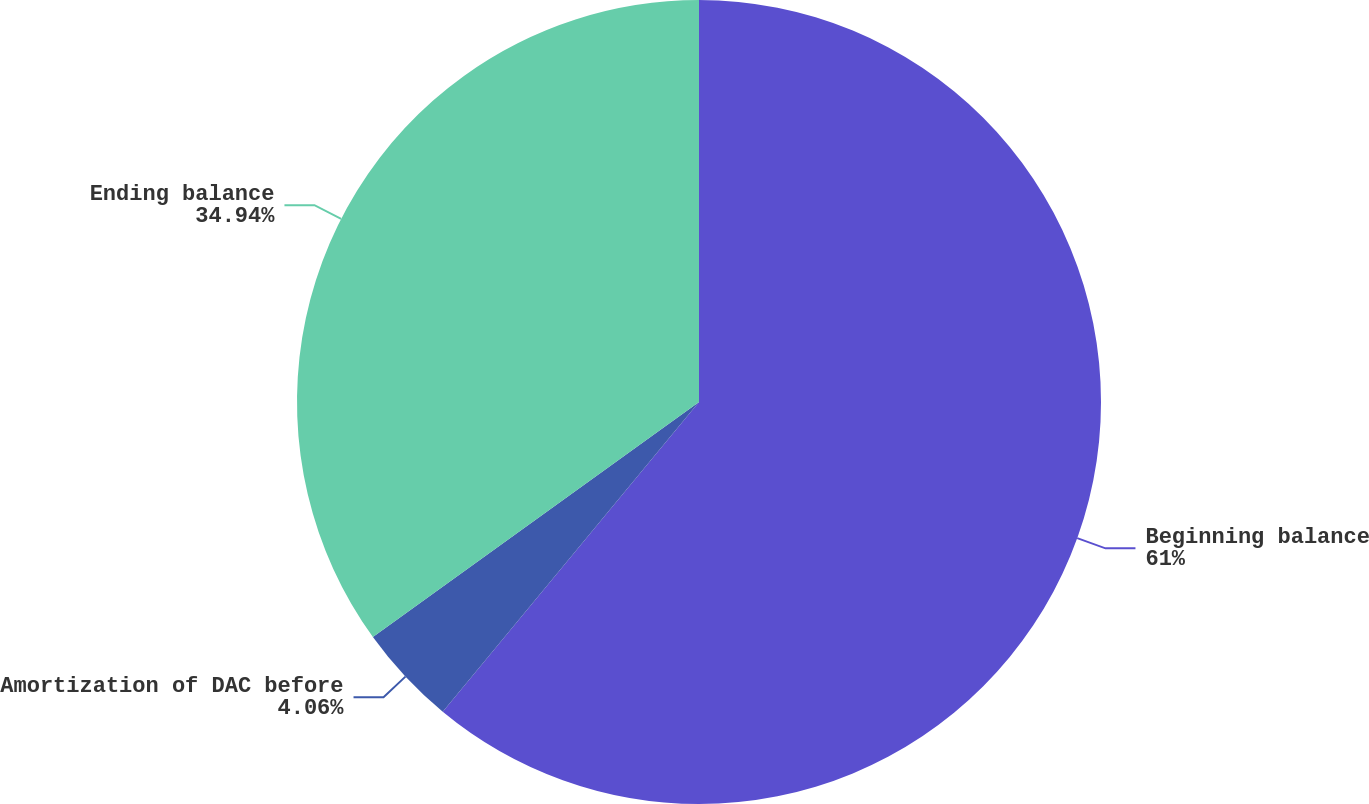<chart> <loc_0><loc_0><loc_500><loc_500><pie_chart><fcel>Beginning balance<fcel>Amortization of DAC before<fcel>Ending balance<nl><fcel>61.0%<fcel>4.06%<fcel>34.94%<nl></chart> 